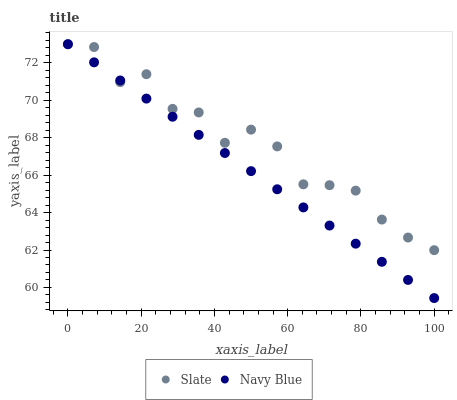Does Navy Blue have the minimum area under the curve?
Answer yes or no. Yes. Does Slate have the maximum area under the curve?
Answer yes or no. Yes. Does Slate have the minimum area under the curve?
Answer yes or no. No. Is Navy Blue the smoothest?
Answer yes or no. Yes. Is Slate the roughest?
Answer yes or no. Yes. Is Slate the smoothest?
Answer yes or no. No. Does Navy Blue have the lowest value?
Answer yes or no. Yes. Does Slate have the lowest value?
Answer yes or no. No. Does Slate have the highest value?
Answer yes or no. Yes. Does Navy Blue intersect Slate?
Answer yes or no. Yes. Is Navy Blue less than Slate?
Answer yes or no. No. Is Navy Blue greater than Slate?
Answer yes or no. No. 